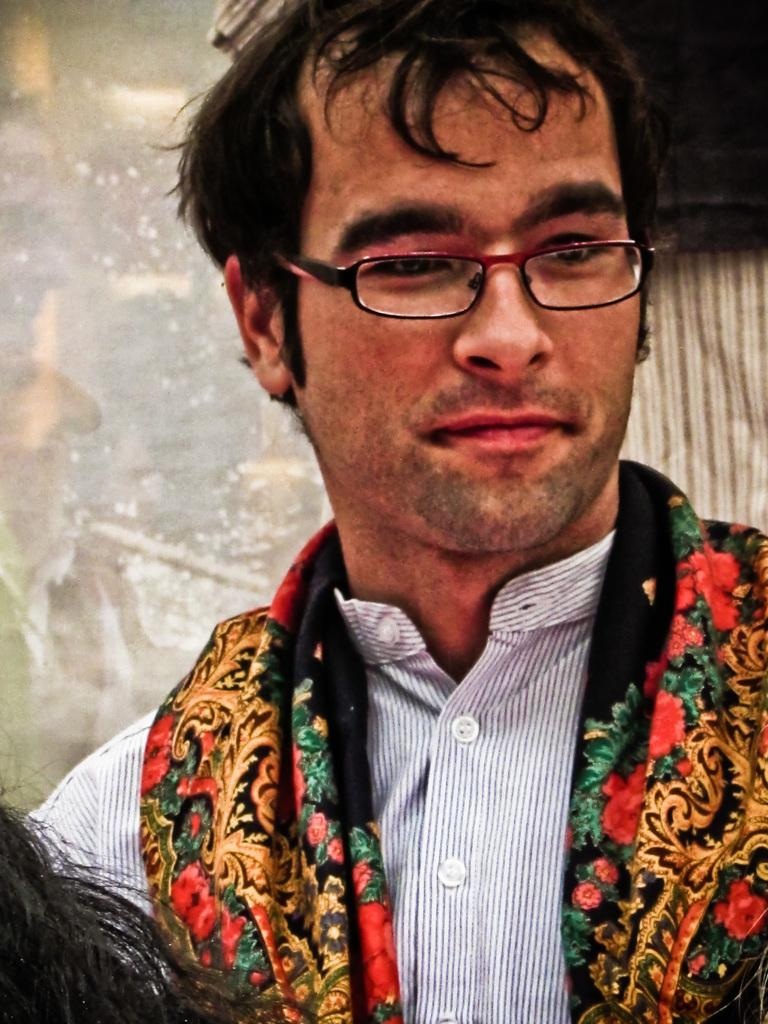Who is present in the image? There is a man in the image. What can be observed about the man's appearance? The man is wearing glasses and a shirt. Can you describe any other details about the man's appearance? There is a person's hair visible on the left side of the image. What can be said about the background of the image? The background of the image is not clear. What type of curtain is being pulled by the man in the image? There is no curtain present in the image, nor is the man depicted as pulling anything. What type of skin condition is visible on the man's face in the image? There is no skin condition visible on the man's face in the image; only his glasses, shirt, and hair are mentioned. 